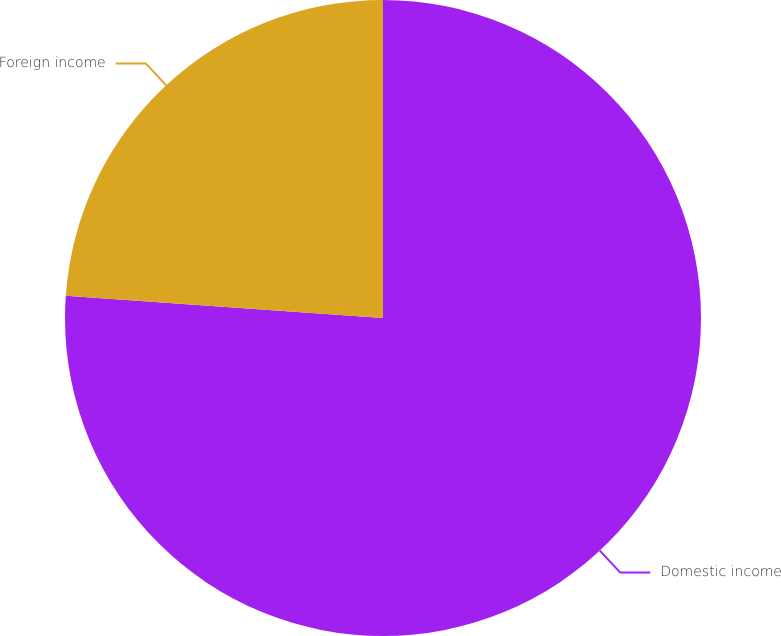<chart> <loc_0><loc_0><loc_500><loc_500><pie_chart><fcel>Domestic income<fcel>Foreign income<nl><fcel>76.12%<fcel>23.88%<nl></chart> 